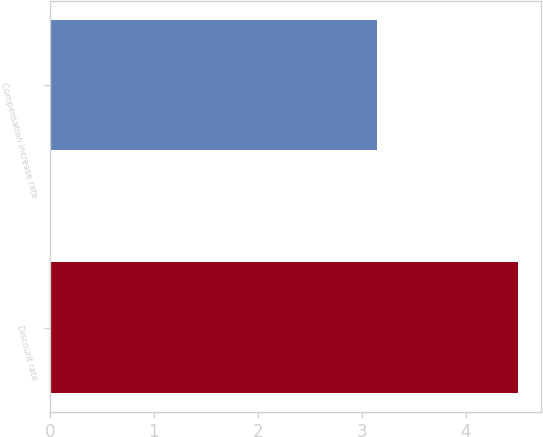<chart> <loc_0><loc_0><loc_500><loc_500><bar_chart><fcel>Discount rate<fcel>Compensation increase rate<nl><fcel>4.5<fcel>3.15<nl></chart> 